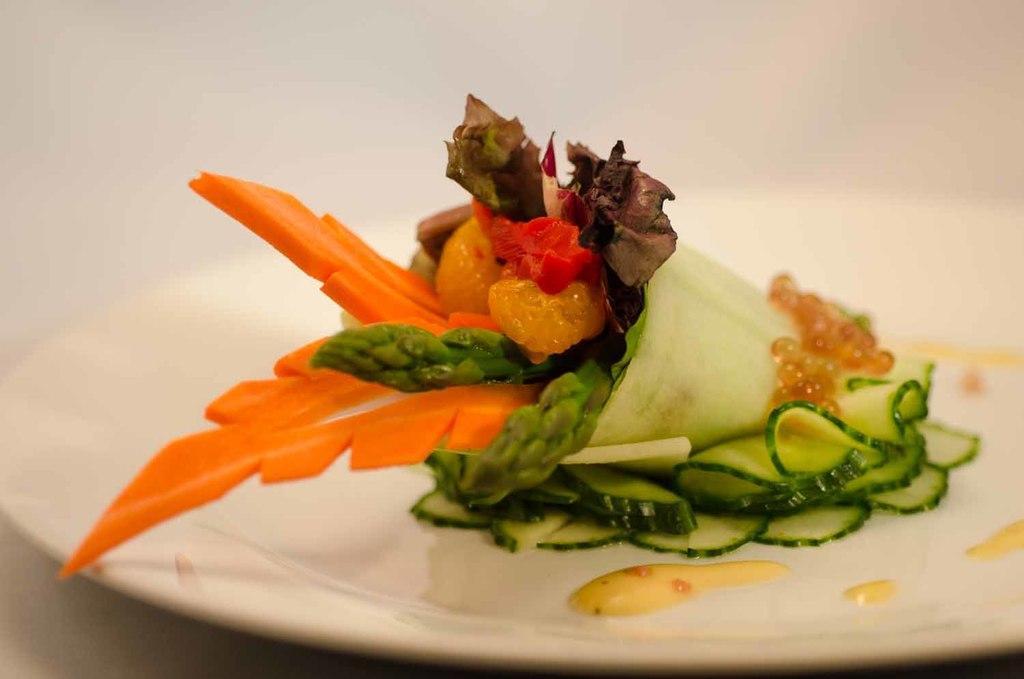In one or two sentences, can you explain what this image depicts? In this image, I can see a food item in a plate. There is a white background. 